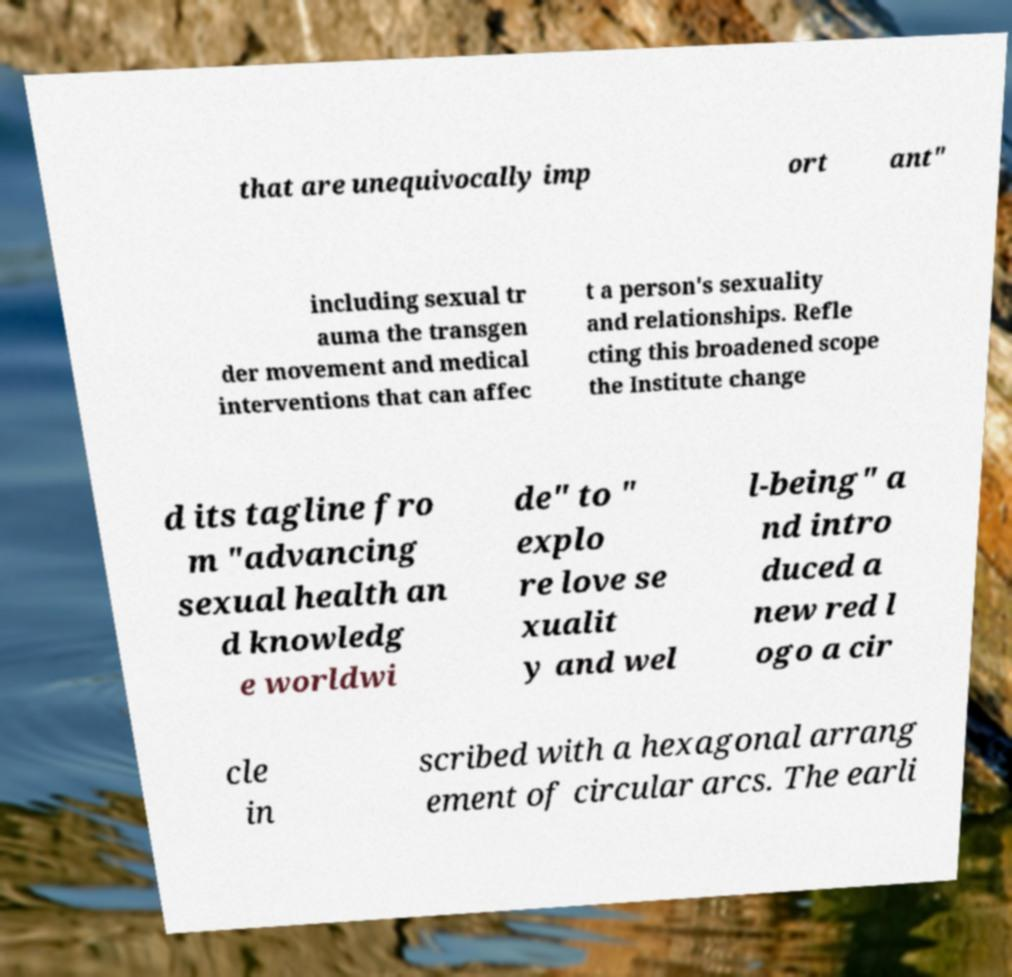Could you assist in decoding the text presented in this image and type it out clearly? that are unequivocally imp ort ant" including sexual tr auma the transgen der movement and medical interventions that can affec t a person's sexuality and relationships. Refle cting this broadened scope the Institute change d its tagline fro m "advancing sexual health an d knowledg e worldwi de" to " explo re love se xualit y and wel l-being" a nd intro duced a new red l ogo a cir cle in scribed with a hexagonal arrang ement of circular arcs. The earli 